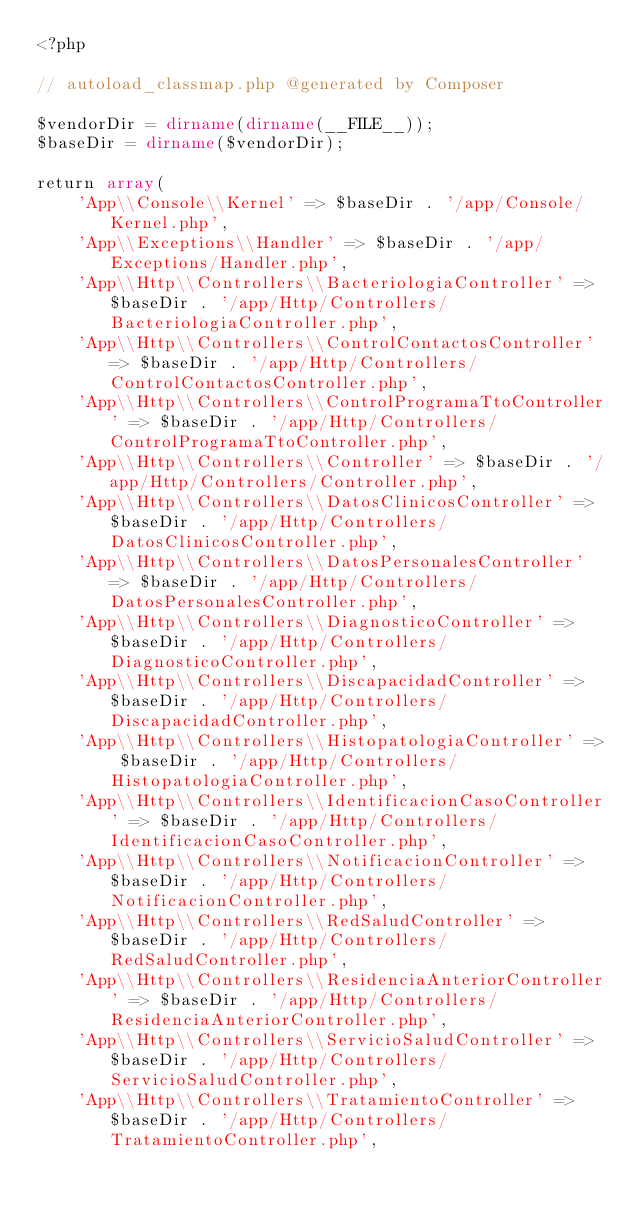<code> <loc_0><loc_0><loc_500><loc_500><_PHP_><?php

// autoload_classmap.php @generated by Composer

$vendorDir = dirname(dirname(__FILE__));
$baseDir = dirname($vendorDir);

return array(
    'App\\Console\\Kernel' => $baseDir . '/app/Console/Kernel.php',
    'App\\Exceptions\\Handler' => $baseDir . '/app/Exceptions/Handler.php',
    'App\\Http\\Controllers\\BacteriologiaController' => $baseDir . '/app/Http/Controllers/BacteriologiaController.php',
    'App\\Http\\Controllers\\ControlContactosController' => $baseDir . '/app/Http/Controllers/ControlContactosController.php',
    'App\\Http\\Controllers\\ControlProgramaTtoController' => $baseDir . '/app/Http/Controllers/ControlProgramaTtoController.php',
    'App\\Http\\Controllers\\Controller' => $baseDir . '/app/Http/Controllers/Controller.php',
    'App\\Http\\Controllers\\DatosClinicosController' => $baseDir . '/app/Http/Controllers/DatosClinicosController.php',
    'App\\Http\\Controllers\\DatosPersonalesController' => $baseDir . '/app/Http/Controllers/DatosPersonalesController.php',
    'App\\Http\\Controllers\\DiagnosticoController' => $baseDir . '/app/Http/Controllers/DiagnosticoController.php',
    'App\\Http\\Controllers\\DiscapacidadController' => $baseDir . '/app/Http/Controllers/DiscapacidadController.php',
    'App\\Http\\Controllers\\HistopatologiaController' => $baseDir . '/app/Http/Controllers/HistopatologiaController.php',
    'App\\Http\\Controllers\\IdentificacionCasoController' => $baseDir . '/app/Http/Controllers/IdentificacionCasoController.php',
    'App\\Http\\Controllers\\NotificacionController' => $baseDir . '/app/Http/Controllers/NotificacionController.php',
    'App\\Http\\Controllers\\RedSaludController' => $baseDir . '/app/Http/Controllers/RedSaludController.php',
    'App\\Http\\Controllers\\ResidenciaAnteriorController' => $baseDir . '/app/Http/Controllers/ResidenciaAnteriorController.php',
    'App\\Http\\Controllers\\ServicioSaludController' => $baseDir . '/app/Http/Controllers/ServicioSaludController.php',
    'App\\Http\\Controllers\\TratamientoController' => $baseDir . '/app/Http/Controllers/TratamientoController.php',</code> 